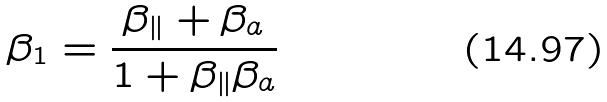Convert formula to latex. <formula><loc_0><loc_0><loc_500><loc_500>\beta _ { 1 } = \frac { \beta _ { \| } + \beta _ { a } } { 1 + \beta _ { \| } \beta _ { a } }</formula> 